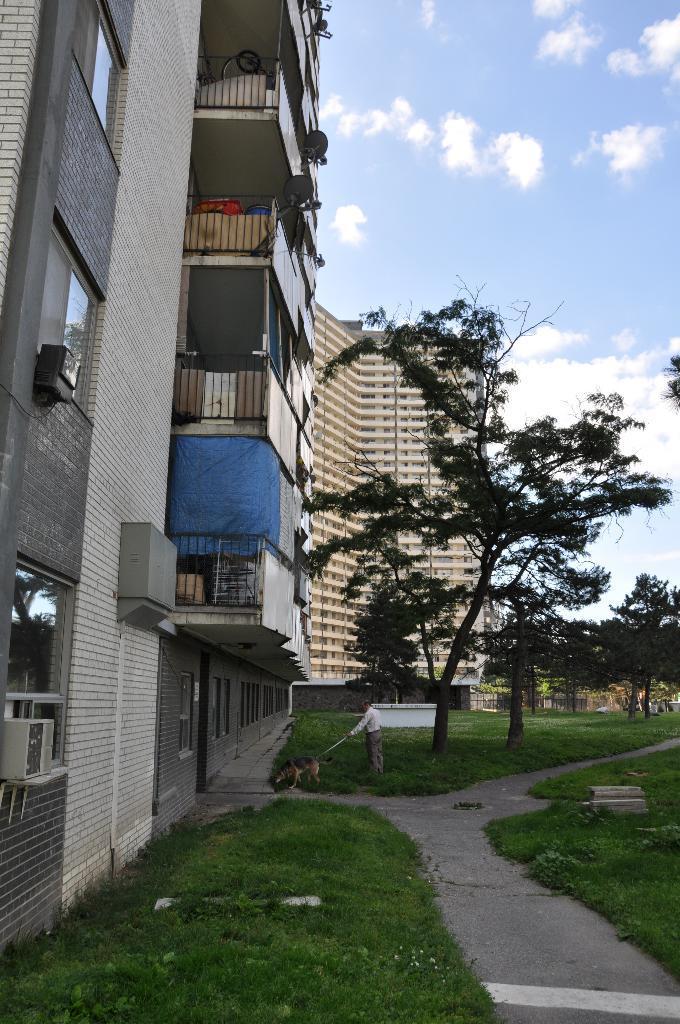How would you summarize this image in a sentence or two? In this image we can see grassy land and trees. Left side of the image buildings are present. The sky is with some clouds. 